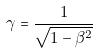<formula> <loc_0><loc_0><loc_500><loc_500>\gamma = \frac { 1 } { \sqrt { 1 - \beta ^ { 2 } } }</formula> 